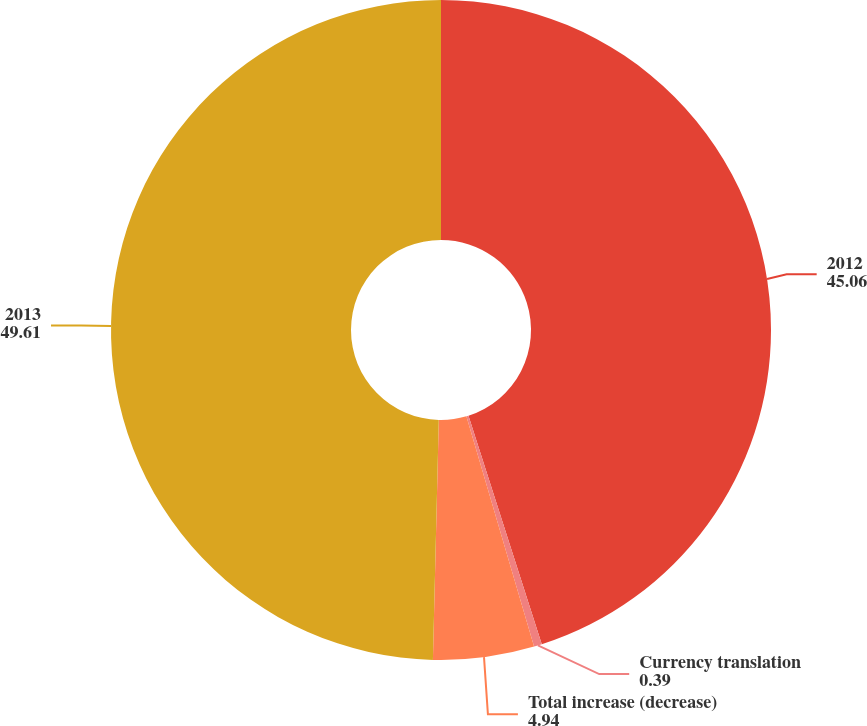Convert chart to OTSL. <chart><loc_0><loc_0><loc_500><loc_500><pie_chart><fcel>2012<fcel>Currency translation<fcel>Total increase (decrease)<fcel>2013<nl><fcel>45.06%<fcel>0.39%<fcel>4.94%<fcel>49.61%<nl></chart> 